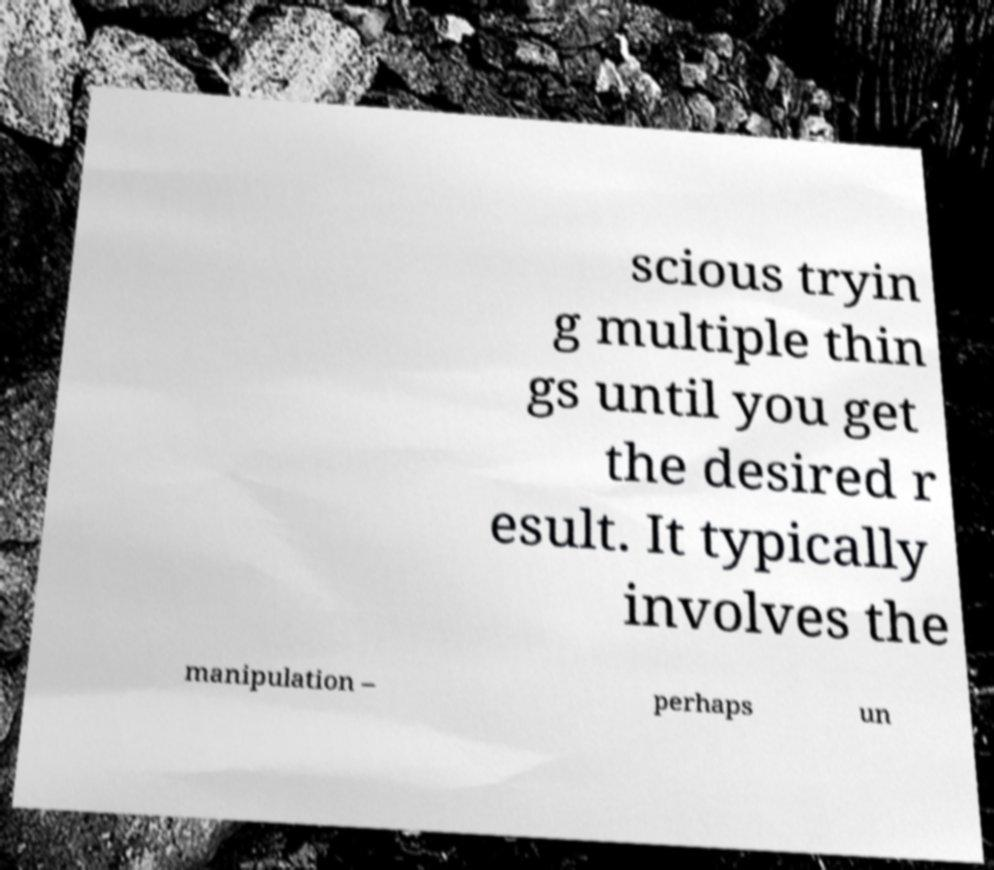Please identify and transcribe the text found in this image. scious tryin g multiple thin gs until you get the desired r esult. It typically involves the manipulation – perhaps un 